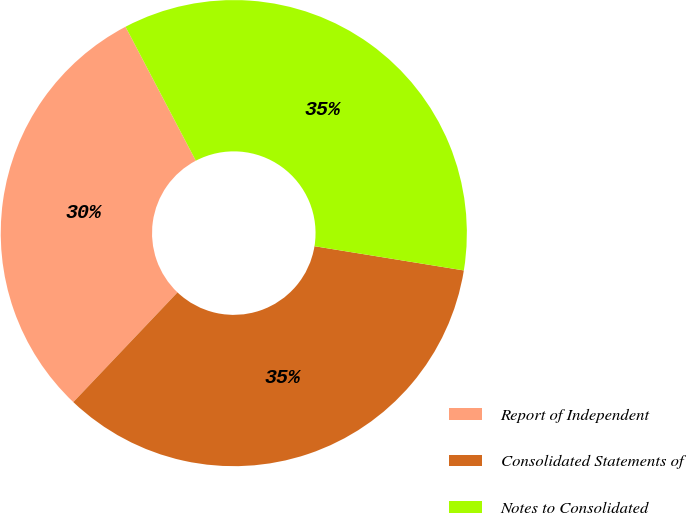Convert chart. <chart><loc_0><loc_0><loc_500><loc_500><pie_chart><fcel>Report of Independent<fcel>Consolidated Statements of<fcel>Notes to Consolidated<nl><fcel>30.22%<fcel>34.53%<fcel>35.25%<nl></chart> 